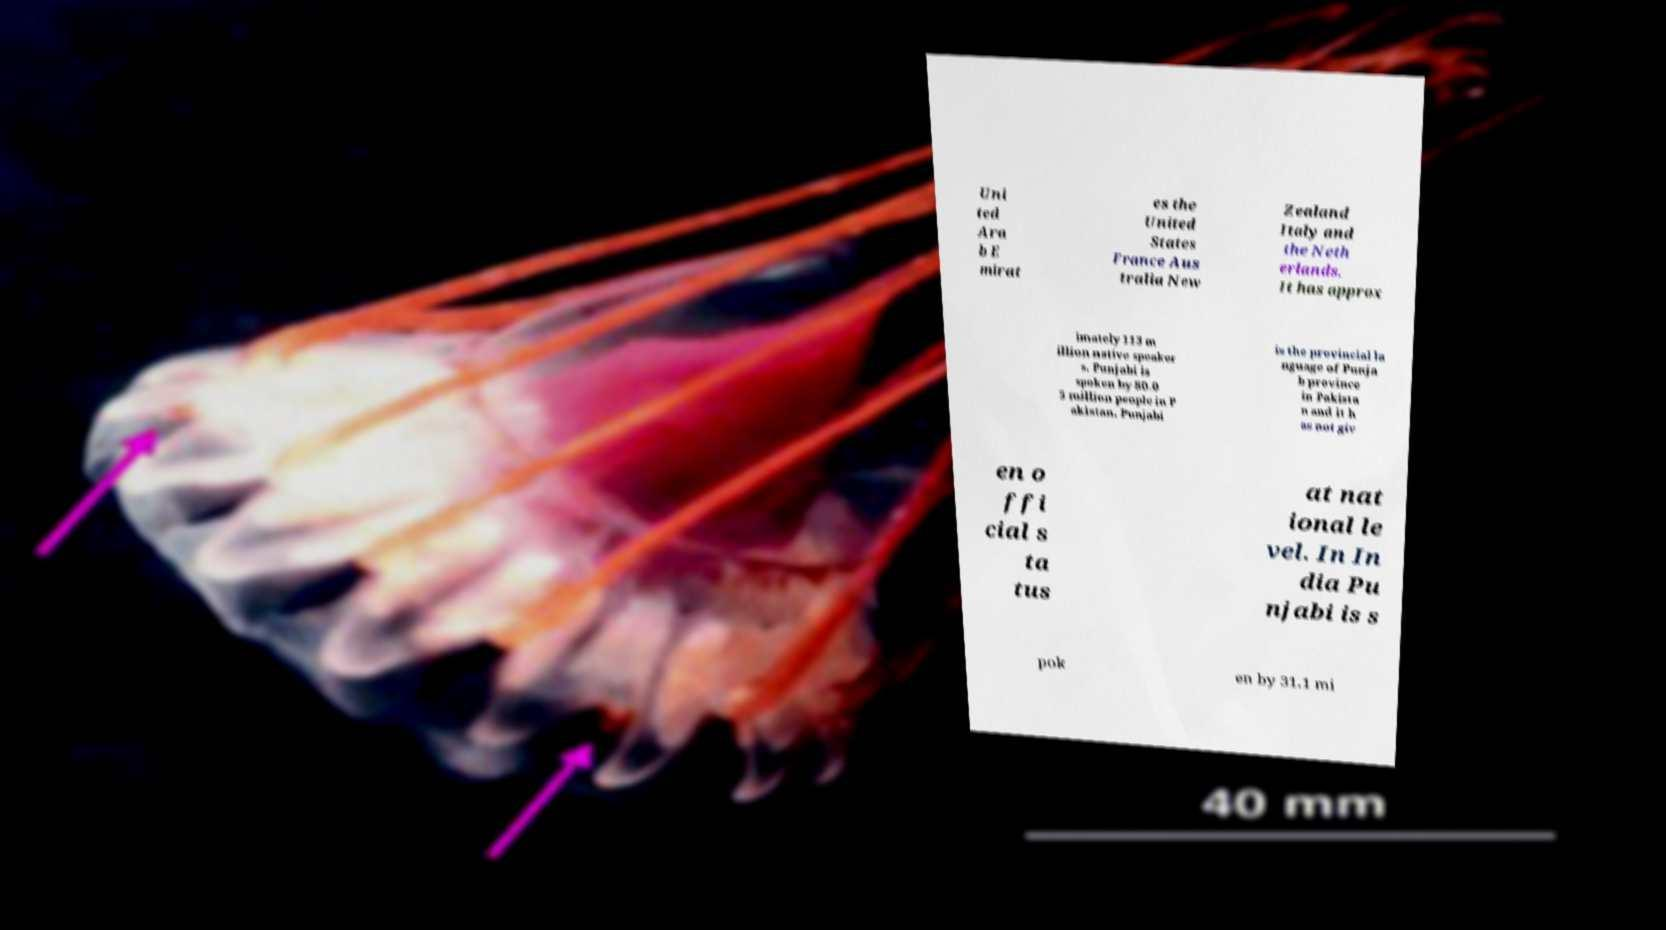Could you assist in decoding the text presented in this image and type it out clearly? Uni ted Ara b E mirat es the United States France Aus tralia New Zealand Italy and the Neth erlands. It has approx imately 113 m illion native speaker s. Punjabi is spoken by 80.0 5 million people in P akistan. Punjabi is the provincial la nguage of Punja b province in Pakista n and it h as not giv en o ffi cial s ta tus at nat ional le vel. In In dia Pu njabi is s pok en by 31.1 mi 